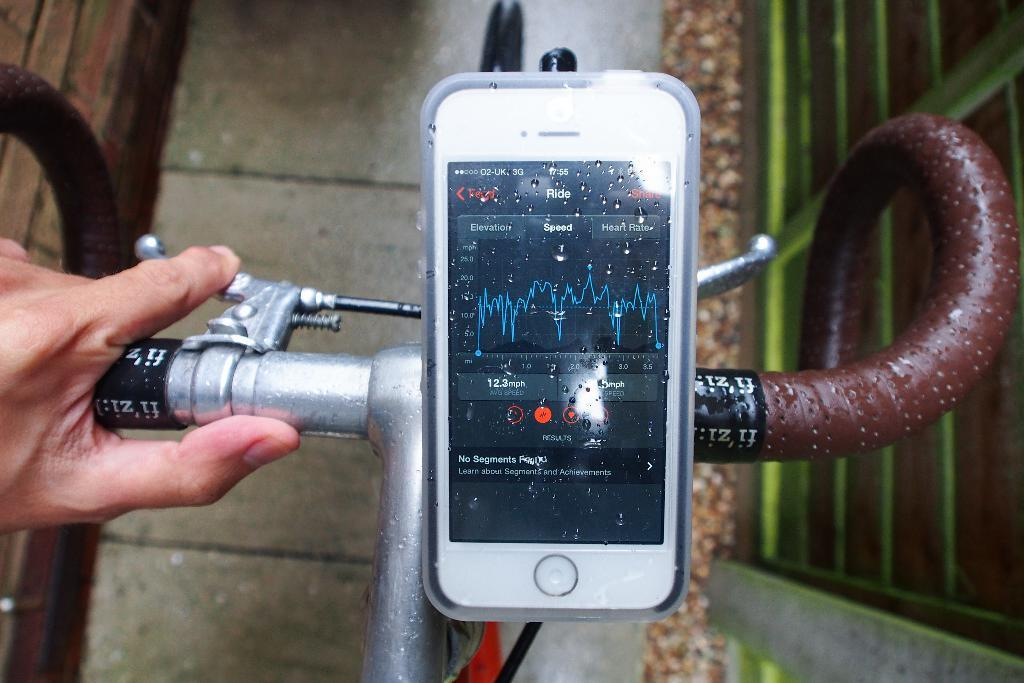<image>
Give a short and clear explanation of the subsequent image. A phone with the word Ride put on it 